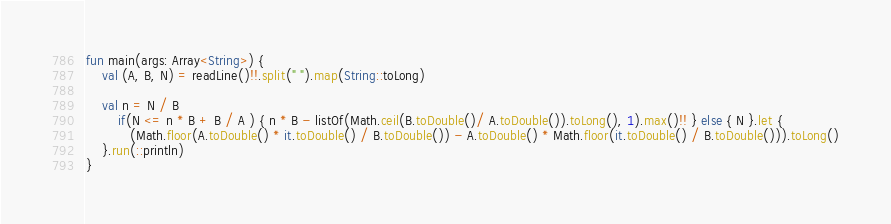<code> <loc_0><loc_0><loc_500><loc_500><_Kotlin_>
fun main(args: Array<String>) {
    val (A, B, N) = readLine()!!.split(" ").map(String::toLong)

    val n = N / B
        if(N <= n * B + B / A ) { n * B - listOf(Math.ceil(B.toDouble()/ A.toDouble()).toLong(), 1).max()!! } else { N }.let {
           (Math.floor(A.toDouble() * it.toDouble() / B.toDouble()) - A.toDouble() * Math.floor(it.toDouble() / B.toDouble())).toLong()
    }.run(::println)
}</code> 